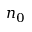<formula> <loc_0><loc_0><loc_500><loc_500>n _ { 0 }</formula> 